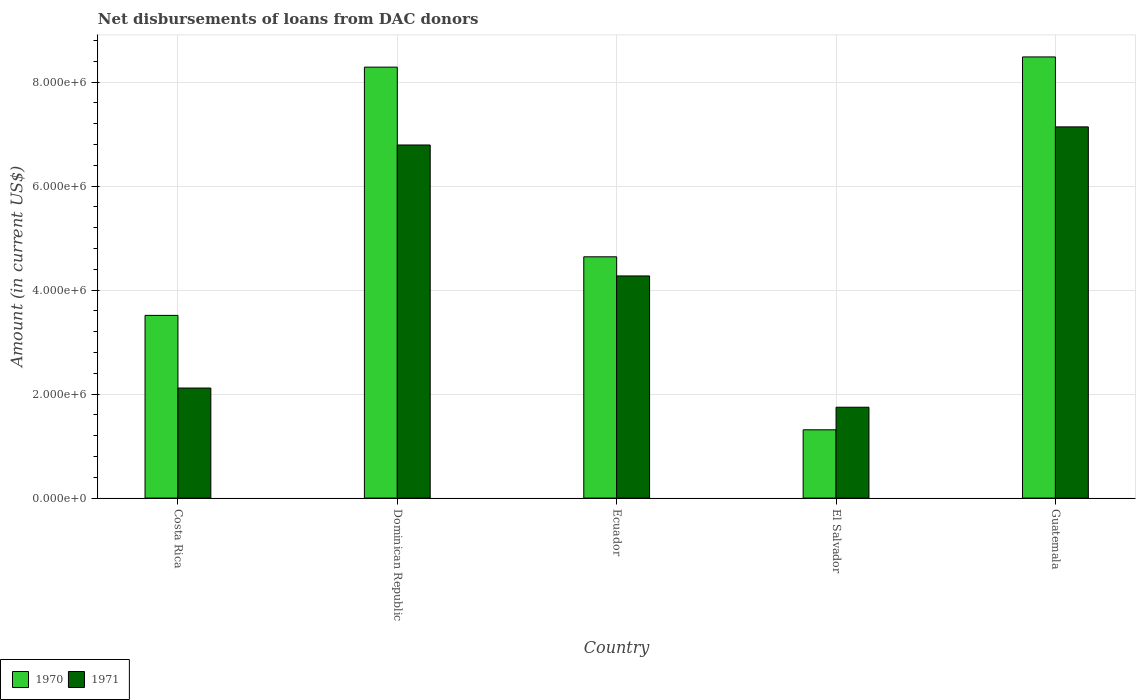What is the label of the 2nd group of bars from the left?
Your answer should be compact. Dominican Republic. What is the amount of loans disbursed in 1970 in Ecuador?
Give a very brief answer. 4.64e+06. Across all countries, what is the maximum amount of loans disbursed in 1971?
Keep it short and to the point. 7.14e+06. Across all countries, what is the minimum amount of loans disbursed in 1970?
Ensure brevity in your answer.  1.31e+06. In which country was the amount of loans disbursed in 1971 maximum?
Your answer should be compact. Guatemala. In which country was the amount of loans disbursed in 1971 minimum?
Offer a terse response. El Salvador. What is the total amount of loans disbursed in 1971 in the graph?
Your answer should be very brief. 2.21e+07. What is the difference between the amount of loans disbursed in 1970 in El Salvador and that in Guatemala?
Your answer should be very brief. -7.17e+06. What is the difference between the amount of loans disbursed in 1971 in El Salvador and the amount of loans disbursed in 1970 in Costa Rica?
Provide a succinct answer. -1.77e+06. What is the average amount of loans disbursed in 1971 per country?
Provide a succinct answer. 4.41e+06. What is the difference between the amount of loans disbursed of/in 1971 and amount of loans disbursed of/in 1970 in Costa Rica?
Keep it short and to the point. -1.40e+06. What is the ratio of the amount of loans disbursed in 1970 in Costa Rica to that in El Salvador?
Give a very brief answer. 2.68. What is the difference between the highest and the second highest amount of loans disbursed in 1970?
Make the answer very short. 3.84e+06. What is the difference between the highest and the lowest amount of loans disbursed in 1970?
Ensure brevity in your answer.  7.17e+06. In how many countries, is the amount of loans disbursed in 1971 greater than the average amount of loans disbursed in 1971 taken over all countries?
Your answer should be compact. 2. Is the sum of the amount of loans disbursed in 1970 in Dominican Republic and Ecuador greater than the maximum amount of loans disbursed in 1971 across all countries?
Your answer should be compact. Yes. What does the 1st bar from the right in Costa Rica represents?
Provide a succinct answer. 1971. How many bars are there?
Make the answer very short. 10. Where does the legend appear in the graph?
Give a very brief answer. Bottom left. What is the title of the graph?
Give a very brief answer. Net disbursements of loans from DAC donors. Does "1963" appear as one of the legend labels in the graph?
Your answer should be compact. No. What is the label or title of the Y-axis?
Ensure brevity in your answer.  Amount (in current US$). What is the Amount (in current US$) in 1970 in Costa Rica?
Ensure brevity in your answer.  3.51e+06. What is the Amount (in current US$) in 1971 in Costa Rica?
Keep it short and to the point. 2.12e+06. What is the Amount (in current US$) in 1970 in Dominican Republic?
Keep it short and to the point. 8.29e+06. What is the Amount (in current US$) in 1971 in Dominican Republic?
Your response must be concise. 6.79e+06. What is the Amount (in current US$) of 1970 in Ecuador?
Offer a very short reply. 4.64e+06. What is the Amount (in current US$) in 1971 in Ecuador?
Ensure brevity in your answer.  4.27e+06. What is the Amount (in current US$) in 1970 in El Salvador?
Your response must be concise. 1.31e+06. What is the Amount (in current US$) of 1971 in El Salvador?
Your response must be concise. 1.75e+06. What is the Amount (in current US$) in 1970 in Guatemala?
Make the answer very short. 8.48e+06. What is the Amount (in current US$) in 1971 in Guatemala?
Your answer should be very brief. 7.14e+06. Across all countries, what is the maximum Amount (in current US$) in 1970?
Keep it short and to the point. 8.48e+06. Across all countries, what is the maximum Amount (in current US$) in 1971?
Provide a short and direct response. 7.14e+06. Across all countries, what is the minimum Amount (in current US$) in 1970?
Keep it short and to the point. 1.31e+06. Across all countries, what is the minimum Amount (in current US$) in 1971?
Give a very brief answer. 1.75e+06. What is the total Amount (in current US$) in 1970 in the graph?
Provide a succinct answer. 2.62e+07. What is the total Amount (in current US$) in 1971 in the graph?
Provide a short and direct response. 2.21e+07. What is the difference between the Amount (in current US$) in 1970 in Costa Rica and that in Dominican Republic?
Your answer should be compact. -4.77e+06. What is the difference between the Amount (in current US$) of 1971 in Costa Rica and that in Dominican Republic?
Make the answer very short. -4.67e+06. What is the difference between the Amount (in current US$) of 1970 in Costa Rica and that in Ecuador?
Give a very brief answer. -1.13e+06. What is the difference between the Amount (in current US$) in 1971 in Costa Rica and that in Ecuador?
Provide a short and direct response. -2.16e+06. What is the difference between the Amount (in current US$) of 1970 in Costa Rica and that in El Salvador?
Offer a very short reply. 2.20e+06. What is the difference between the Amount (in current US$) of 1971 in Costa Rica and that in El Salvador?
Provide a succinct answer. 3.69e+05. What is the difference between the Amount (in current US$) of 1970 in Costa Rica and that in Guatemala?
Your answer should be compact. -4.97e+06. What is the difference between the Amount (in current US$) in 1971 in Costa Rica and that in Guatemala?
Offer a very short reply. -5.02e+06. What is the difference between the Amount (in current US$) of 1970 in Dominican Republic and that in Ecuador?
Your answer should be compact. 3.65e+06. What is the difference between the Amount (in current US$) of 1971 in Dominican Republic and that in Ecuador?
Offer a terse response. 2.52e+06. What is the difference between the Amount (in current US$) in 1970 in Dominican Republic and that in El Salvador?
Provide a short and direct response. 6.97e+06. What is the difference between the Amount (in current US$) of 1971 in Dominican Republic and that in El Salvador?
Provide a succinct answer. 5.04e+06. What is the difference between the Amount (in current US$) in 1970 in Dominican Republic and that in Guatemala?
Ensure brevity in your answer.  -1.96e+05. What is the difference between the Amount (in current US$) in 1971 in Dominican Republic and that in Guatemala?
Provide a short and direct response. -3.48e+05. What is the difference between the Amount (in current US$) in 1970 in Ecuador and that in El Salvador?
Give a very brief answer. 3.33e+06. What is the difference between the Amount (in current US$) in 1971 in Ecuador and that in El Salvador?
Ensure brevity in your answer.  2.52e+06. What is the difference between the Amount (in current US$) in 1970 in Ecuador and that in Guatemala?
Offer a very short reply. -3.84e+06. What is the difference between the Amount (in current US$) in 1971 in Ecuador and that in Guatemala?
Make the answer very short. -2.87e+06. What is the difference between the Amount (in current US$) in 1970 in El Salvador and that in Guatemala?
Provide a succinct answer. -7.17e+06. What is the difference between the Amount (in current US$) of 1971 in El Salvador and that in Guatemala?
Offer a very short reply. -5.39e+06. What is the difference between the Amount (in current US$) of 1970 in Costa Rica and the Amount (in current US$) of 1971 in Dominican Republic?
Provide a short and direct response. -3.28e+06. What is the difference between the Amount (in current US$) of 1970 in Costa Rica and the Amount (in current US$) of 1971 in Ecuador?
Ensure brevity in your answer.  -7.58e+05. What is the difference between the Amount (in current US$) of 1970 in Costa Rica and the Amount (in current US$) of 1971 in El Salvador?
Ensure brevity in your answer.  1.77e+06. What is the difference between the Amount (in current US$) in 1970 in Costa Rica and the Amount (in current US$) in 1971 in Guatemala?
Your answer should be compact. -3.62e+06. What is the difference between the Amount (in current US$) in 1970 in Dominican Republic and the Amount (in current US$) in 1971 in Ecuador?
Offer a terse response. 4.02e+06. What is the difference between the Amount (in current US$) of 1970 in Dominican Republic and the Amount (in current US$) of 1971 in El Salvador?
Provide a succinct answer. 6.54e+06. What is the difference between the Amount (in current US$) of 1970 in Dominican Republic and the Amount (in current US$) of 1971 in Guatemala?
Give a very brief answer. 1.15e+06. What is the difference between the Amount (in current US$) of 1970 in Ecuador and the Amount (in current US$) of 1971 in El Salvador?
Make the answer very short. 2.89e+06. What is the difference between the Amount (in current US$) in 1970 in Ecuador and the Amount (in current US$) in 1971 in Guatemala?
Ensure brevity in your answer.  -2.50e+06. What is the difference between the Amount (in current US$) in 1970 in El Salvador and the Amount (in current US$) in 1971 in Guatemala?
Your answer should be very brief. -5.82e+06. What is the average Amount (in current US$) in 1970 per country?
Keep it short and to the point. 5.25e+06. What is the average Amount (in current US$) in 1971 per country?
Provide a succinct answer. 4.41e+06. What is the difference between the Amount (in current US$) in 1970 and Amount (in current US$) in 1971 in Costa Rica?
Your answer should be compact. 1.40e+06. What is the difference between the Amount (in current US$) in 1970 and Amount (in current US$) in 1971 in Dominican Republic?
Give a very brief answer. 1.50e+06. What is the difference between the Amount (in current US$) of 1970 and Amount (in current US$) of 1971 in Ecuador?
Offer a terse response. 3.68e+05. What is the difference between the Amount (in current US$) in 1970 and Amount (in current US$) in 1971 in El Salvador?
Offer a terse response. -4.34e+05. What is the difference between the Amount (in current US$) in 1970 and Amount (in current US$) in 1971 in Guatemala?
Your answer should be very brief. 1.34e+06. What is the ratio of the Amount (in current US$) of 1970 in Costa Rica to that in Dominican Republic?
Provide a short and direct response. 0.42. What is the ratio of the Amount (in current US$) in 1971 in Costa Rica to that in Dominican Republic?
Offer a terse response. 0.31. What is the ratio of the Amount (in current US$) of 1970 in Costa Rica to that in Ecuador?
Give a very brief answer. 0.76. What is the ratio of the Amount (in current US$) of 1971 in Costa Rica to that in Ecuador?
Provide a short and direct response. 0.5. What is the ratio of the Amount (in current US$) in 1970 in Costa Rica to that in El Salvador?
Keep it short and to the point. 2.68. What is the ratio of the Amount (in current US$) of 1971 in Costa Rica to that in El Salvador?
Keep it short and to the point. 1.21. What is the ratio of the Amount (in current US$) of 1970 in Costa Rica to that in Guatemala?
Give a very brief answer. 0.41. What is the ratio of the Amount (in current US$) in 1971 in Costa Rica to that in Guatemala?
Your answer should be very brief. 0.3. What is the ratio of the Amount (in current US$) in 1970 in Dominican Republic to that in Ecuador?
Give a very brief answer. 1.79. What is the ratio of the Amount (in current US$) in 1971 in Dominican Republic to that in Ecuador?
Ensure brevity in your answer.  1.59. What is the ratio of the Amount (in current US$) of 1970 in Dominican Republic to that in El Salvador?
Provide a short and direct response. 6.31. What is the ratio of the Amount (in current US$) in 1971 in Dominican Republic to that in El Salvador?
Your answer should be compact. 3.89. What is the ratio of the Amount (in current US$) of 1970 in Dominican Republic to that in Guatemala?
Your answer should be compact. 0.98. What is the ratio of the Amount (in current US$) in 1971 in Dominican Republic to that in Guatemala?
Offer a terse response. 0.95. What is the ratio of the Amount (in current US$) in 1970 in Ecuador to that in El Salvador?
Make the answer very short. 3.53. What is the ratio of the Amount (in current US$) of 1971 in Ecuador to that in El Salvador?
Your response must be concise. 2.44. What is the ratio of the Amount (in current US$) of 1970 in Ecuador to that in Guatemala?
Keep it short and to the point. 0.55. What is the ratio of the Amount (in current US$) of 1971 in Ecuador to that in Guatemala?
Your answer should be very brief. 0.6. What is the ratio of the Amount (in current US$) of 1970 in El Salvador to that in Guatemala?
Provide a short and direct response. 0.15. What is the ratio of the Amount (in current US$) in 1971 in El Salvador to that in Guatemala?
Offer a very short reply. 0.24. What is the difference between the highest and the second highest Amount (in current US$) in 1970?
Provide a succinct answer. 1.96e+05. What is the difference between the highest and the second highest Amount (in current US$) in 1971?
Make the answer very short. 3.48e+05. What is the difference between the highest and the lowest Amount (in current US$) in 1970?
Keep it short and to the point. 7.17e+06. What is the difference between the highest and the lowest Amount (in current US$) in 1971?
Provide a succinct answer. 5.39e+06. 